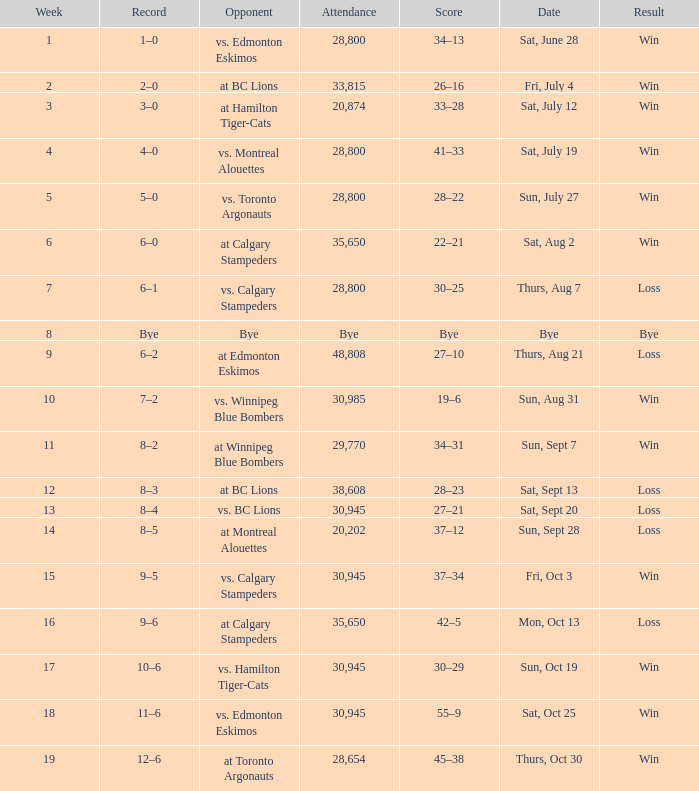What was the record the the match against vs. calgary stampeders before week 15? 6–1. 